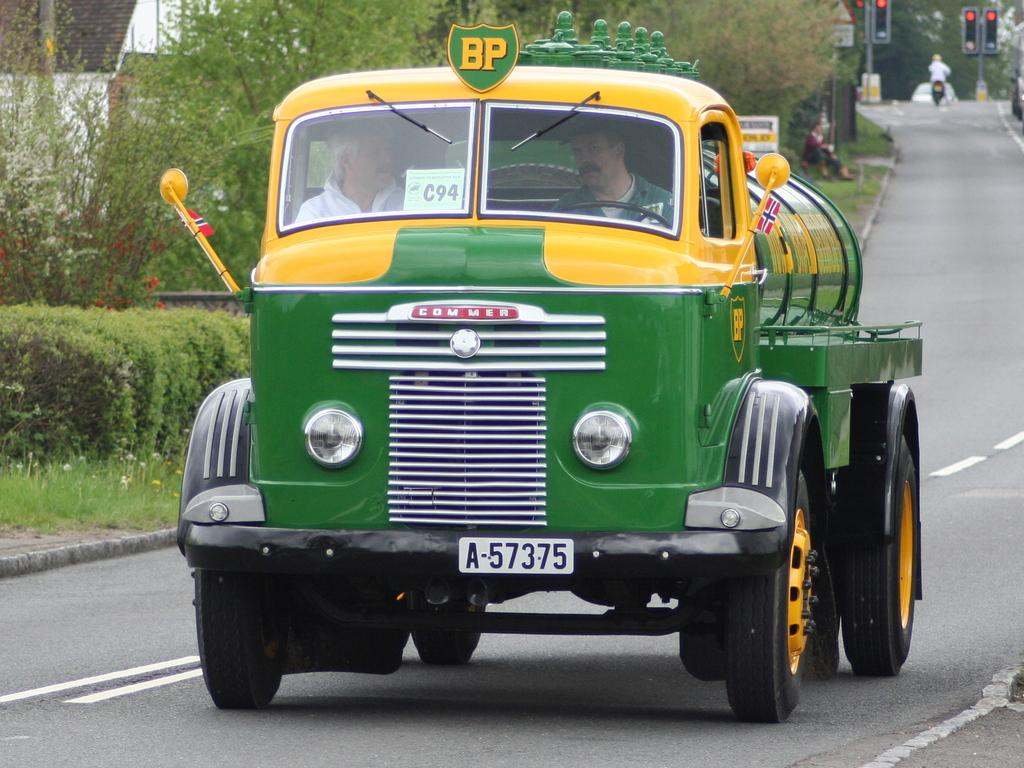<image>
Give a short and clear explanation of the subsequent image. a green truck that says 'commer' on the front of it 